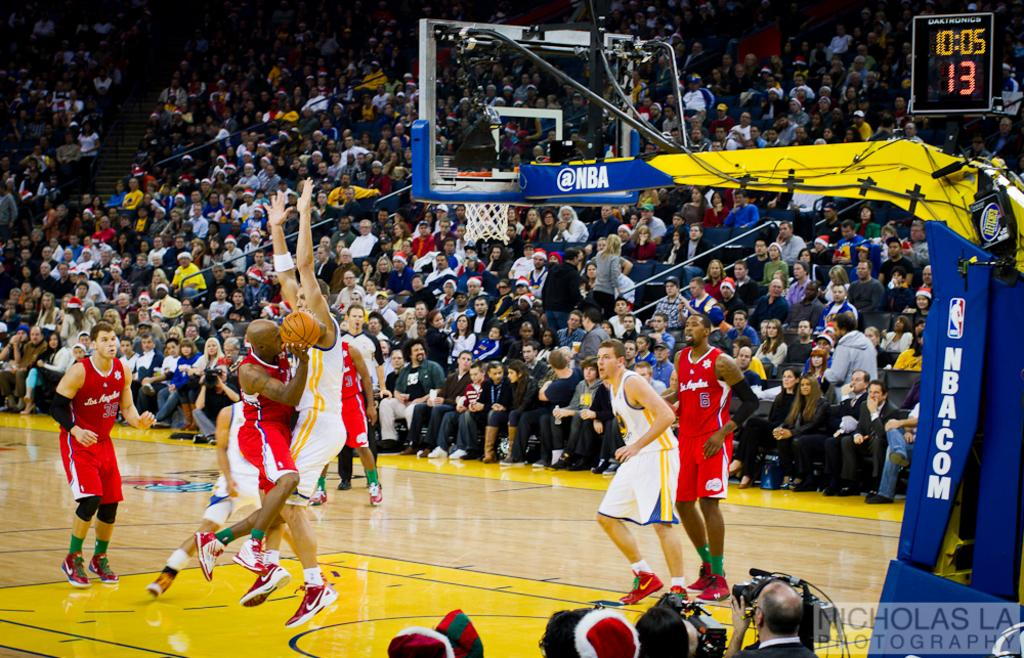<image>
Summarize the visual content of the image. The shot clock in this NBA game reads 13 seconds. 